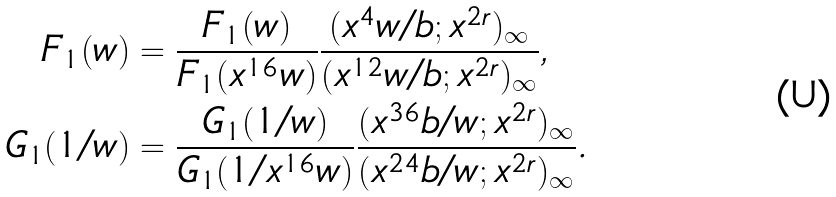<formula> <loc_0><loc_0><loc_500><loc_500>\ F _ { 1 } ( w ) & = \frac { F _ { 1 } ( w ) } { F _ { 1 } ( x ^ { 1 6 } w ) } \frac { ( x ^ { 4 } w / b ; x ^ { 2 r } ) _ { \infty } } { ( x ^ { 1 2 } w / b ; x ^ { 2 r } ) _ { \infty } } , \\ \ G _ { 1 } ( 1 / w ) & = \frac { G _ { 1 } ( 1 / w ) } { G _ { 1 } ( 1 / x ^ { 1 6 } w ) } \frac { ( x ^ { 3 6 } b / w ; x ^ { 2 r } ) _ { \infty } } { ( x ^ { 2 4 } b / w ; x ^ { 2 r } ) _ { \infty } } .</formula> 